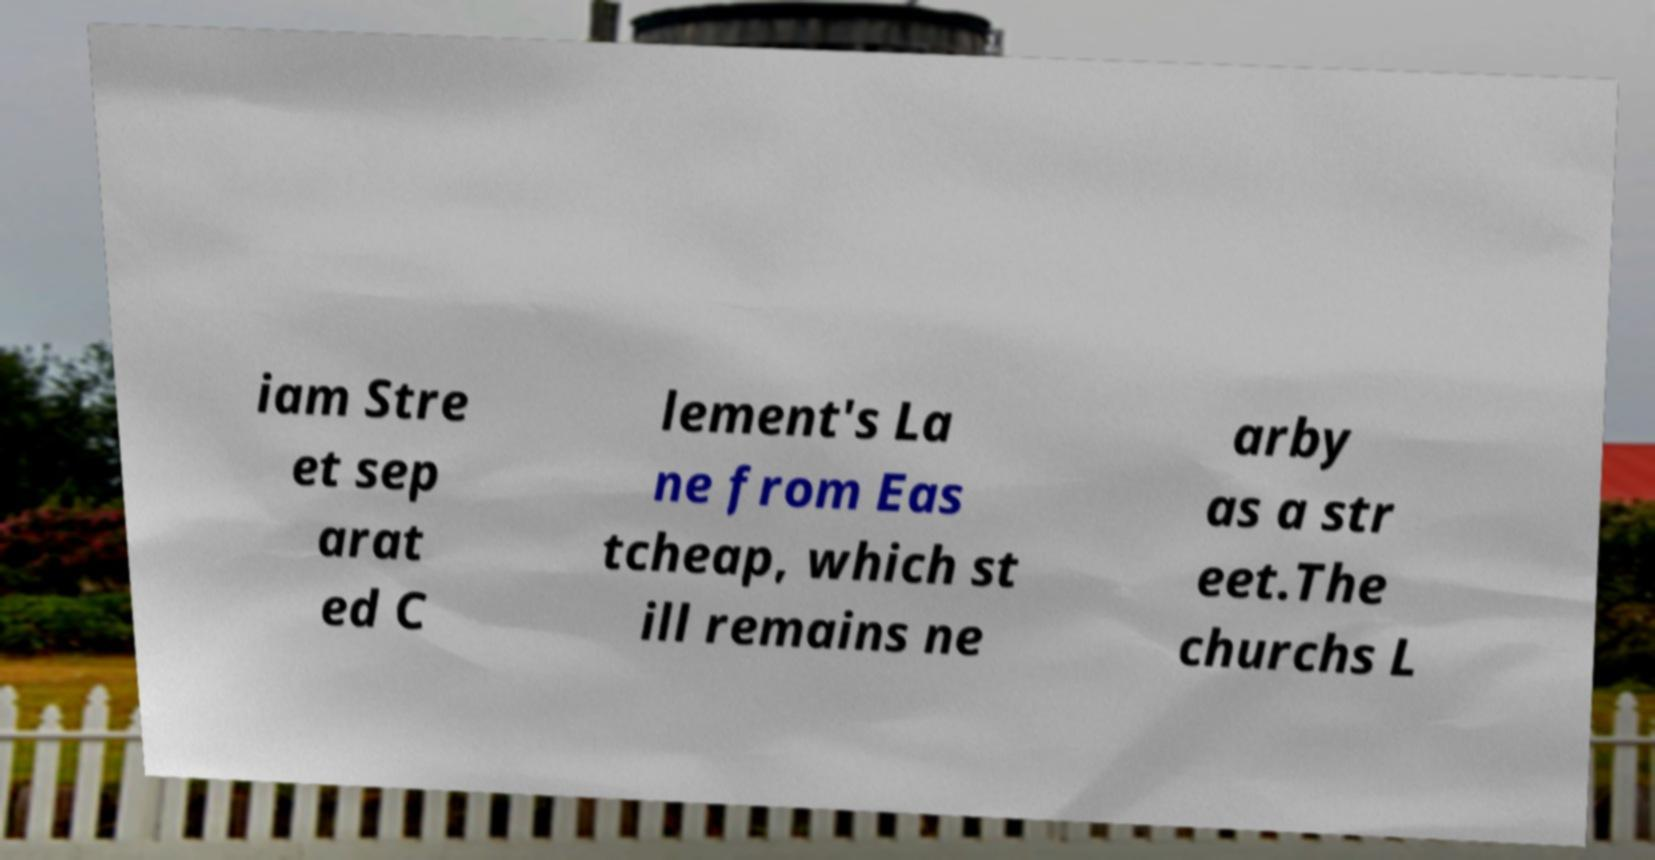What messages or text are displayed in this image? I need them in a readable, typed format. iam Stre et sep arat ed C lement's La ne from Eas tcheap, which st ill remains ne arby as a str eet.The churchs L 